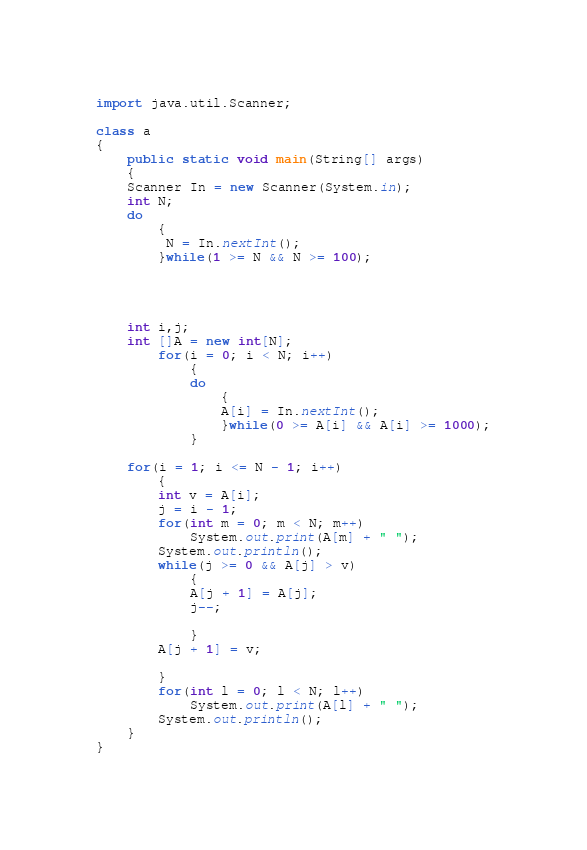Convert code to text. <code><loc_0><loc_0><loc_500><loc_500><_Java_>import java.util.Scanner;

class a
{
    public static void main(String[] args)
    {
	Scanner In = new Scanner(System.in);
	int N;
	do
	    {
		 N = In.nextInt();
	    }while(1 >= N && N >= 100);



	
	int i,j;
	int []A = new int[N];
		for(i = 0; i < N; i++)
		    {
			do
			    {
				A[i] = In.nextInt();
			    }while(0 >= A[i] && A[i] >= 1000);
		    }
	
	for(i = 1; i <= N - 1; i++)
	    {
		int v = A[i];
		j = i - 1;
		for(int m = 0; m < N; m++)
		    System.out.print(A[m] + " ");
		System.out.println();
		while(j >= 0 && A[j] > v)
		    {
			A[j + 1] = A[j];
			j--;
			
		    }
		A[j + 1] = v;
	
	    }
		for(int l = 0; l < N; l++)
		    System.out.print(A[l] + " ");
		System.out.println();
    }
}</code> 